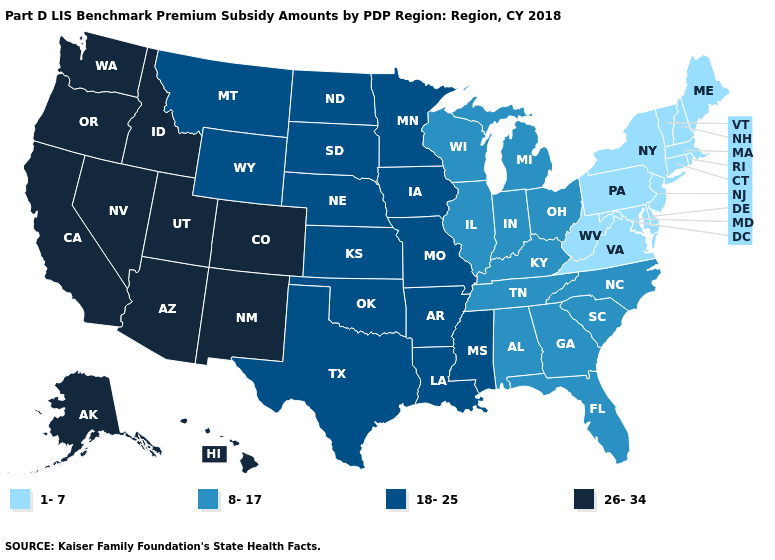Name the states that have a value in the range 26-34?
Quick response, please. Alaska, Arizona, California, Colorado, Hawaii, Idaho, Nevada, New Mexico, Oregon, Utah, Washington. Name the states that have a value in the range 26-34?
Be succinct. Alaska, Arizona, California, Colorado, Hawaii, Idaho, Nevada, New Mexico, Oregon, Utah, Washington. Is the legend a continuous bar?
Concise answer only. No. Among the states that border Indiana , which have the lowest value?
Concise answer only. Illinois, Kentucky, Michigan, Ohio. What is the value of Wisconsin?
Be succinct. 8-17. What is the value of Missouri?
Answer briefly. 18-25. What is the highest value in the USA?
Keep it brief. 26-34. Does the map have missing data?
Write a very short answer. No. How many symbols are there in the legend?
Write a very short answer. 4. What is the value of North Dakota?
Be succinct. 18-25. What is the highest value in the MidWest ?
Keep it brief. 18-25. Does Connecticut have a lower value than New York?
Quick response, please. No. Does Hawaii have the highest value in the USA?
Concise answer only. Yes. What is the lowest value in the South?
Keep it brief. 1-7. What is the value of Georgia?
Give a very brief answer. 8-17. 